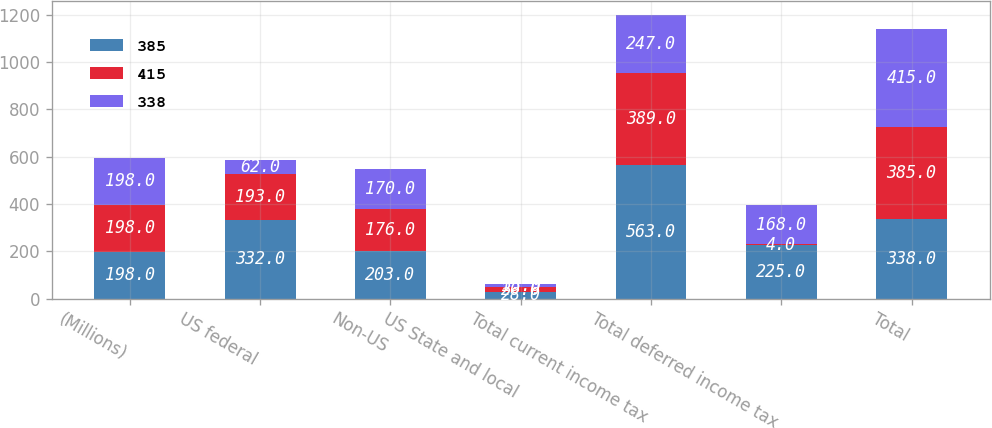Convert chart to OTSL. <chart><loc_0><loc_0><loc_500><loc_500><stacked_bar_chart><ecel><fcel>(Millions)<fcel>US federal<fcel>Non-US<fcel>US State and local<fcel>Total current income tax<fcel>Total deferred income tax<fcel>Total<nl><fcel>385<fcel>198<fcel>332<fcel>203<fcel>28<fcel>563<fcel>225<fcel>338<nl><fcel>415<fcel>198<fcel>193<fcel>176<fcel>20<fcel>389<fcel>4<fcel>385<nl><fcel>338<fcel>198<fcel>62<fcel>170<fcel>15<fcel>247<fcel>168<fcel>415<nl></chart> 